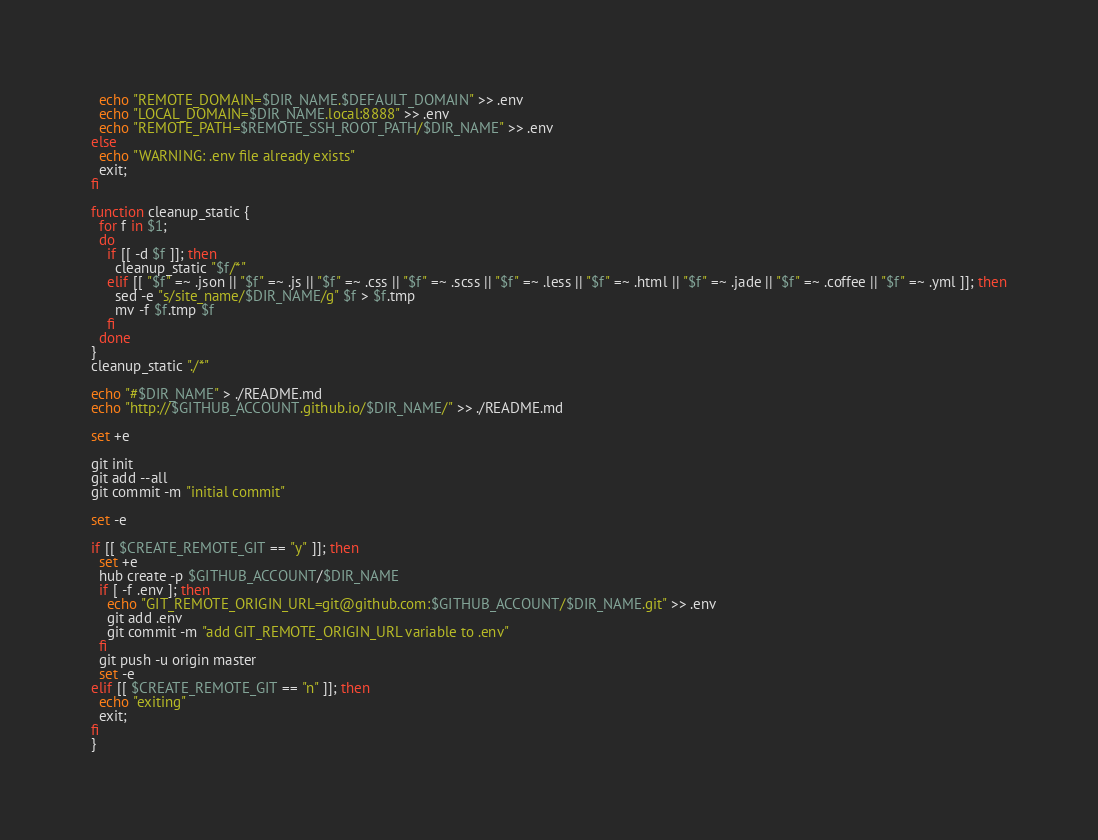<code> <loc_0><loc_0><loc_500><loc_500><_Bash_>  echo "REMOTE_DOMAIN=$DIR_NAME.$DEFAULT_DOMAIN" >> .env
  echo "LOCAL_DOMAIN=$DIR_NAME.local:8888" >> .env
  echo "REMOTE_PATH=$REMOTE_SSH_ROOT_PATH/$DIR_NAME" >> .env
else
  echo "WARNING: .env file already exists"
  exit;
fi

function cleanup_static {
  for f in $1;
  do
    if [[ -d $f ]]; then
      cleanup_static "$f/*"
    elif [[ "$f" =~ .json || "$f" =~ .js || "$f" =~ .css || "$f" =~ .scss || "$f" =~ .less || "$f" =~ .html || "$f" =~ .jade || "$f" =~ .coffee || "$f" =~ .yml ]]; then
      sed -e "s/site_name/$DIR_NAME/g" $f > $f.tmp
      mv -f $f.tmp $f
    fi
  done
}
cleanup_static "./*"

echo "#$DIR_NAME" > ./README.md
echo "http://$GITHUB_ACCOUNT.github.io/$DIR_NAME/" >> ./README.md

set +e

git init
git add --all
git commit -m "initial commit"

set -e

if [[ $CREATE_REMOTE_GIT == "y" ]]; then
  set +e
  hub create -p $GITHUB_ACCOUNT/$DIR_NAME
  if [ -f .env ]; then
    echo "GIT_REMOTE_ORIGIN_URL=git@github.com:$GITHUB_ACCOUNT/$DIR_NAME.git" >> .env
    git add .env
    git commit -m "add GIT_REMOTE_ORIGIN_URL variable to .env"
  fi
  git push -u origin master
  set -e
elif [[ $CREATE_REMOTE_GIT == "n" ]]; then
  echo "exiting"
  exit;
fi
}
</code> 